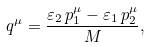<formula> <loc_0><loc_0><loc_500><loc_500>q ^ { \mu } = \frac { \varepsilon _ { 2 } \, p ^ { \mu } _ { 1 } - \varepsilon _ { 1 } \, p ^ { \mu } _ { 2 } } { M } ,</formula> 